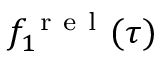<formula> <loc_0><loc_0><loc_500><loc_500>f _ { 1 } ^ { r e l } ( \tau )</formula> 